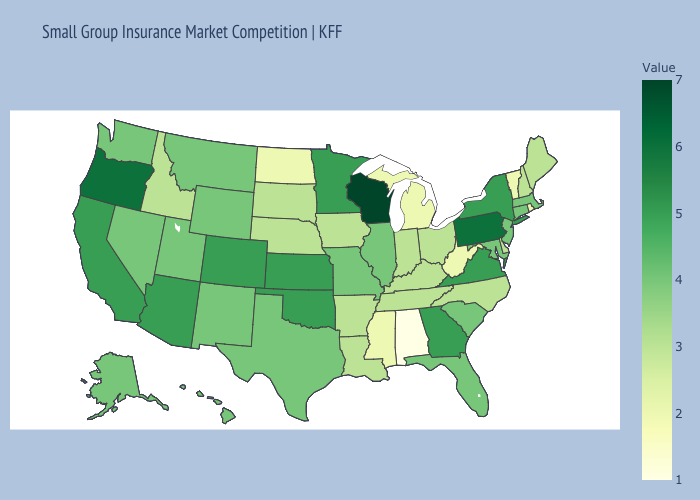Does Georgia have a lower value than Pennsylvania?
Keep it brief. Yes. Does the map have missing data?
Be succinct. No. Does Wyoming have the lowest value in the West?
Write a very short answer. No. Does Hawaii have the lowest value in the USA?
Quick response, please. No. Does Alabama have the lowest value in the South?
Write a very short answer. Yes. 